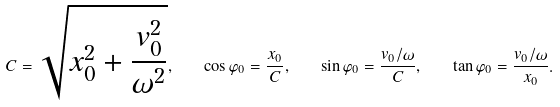<formula> <loc_0><loc_0><loc_500><loc_500>C = \sqrt { x ^ { 2 } _ { 0 } + \frac { v ^ { 2 } _ { 0 } } { \omega ^ { 2 } } } , \quad \cos \varphi _ { 0 } = \frac { x _ { 0 } } { C } , \quad \sin \varphi _ { 0 } = \frac { v _ { 0 } / \omega } { C } , \quad \tan \varphi _ { 0 } = \frac { v _ { 0 } / \omega } { x _ { 0 } } .</formula> 